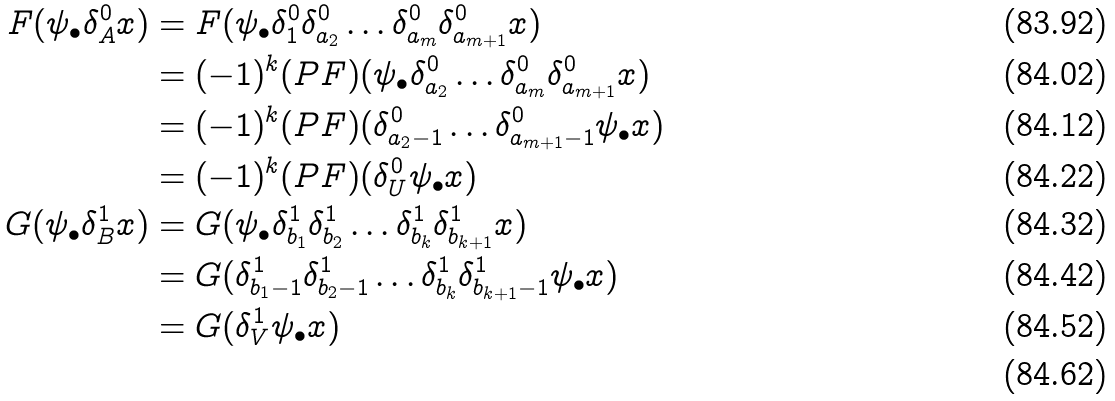Convert formula to latex. <formula><loc_0><loc_0><loc_500><loc_500>F ( \psi _ { \bullet } \delta ^ { 0 } _ { A } x ) & = F ( \psi _ { \bullet } \delta ^ { 0 } _ { 1 } \delta ^ { 0 } _ { a _ { 2 } } \dots \delta ^ { 0 } _ { a _ { m } } \delta ^ { 0 } _ { a _ { m + 1 } } x ) \\ & = ( - 1 ) ^ { k } ( P F ) ( \psi _ { \bullet } \delta ^ { 0 } _ { a _ { 2 } } \dots \delta ^ { 0 } _ { a _ { m } } \delta ^ { 0 } _ { a _ { m + 1 } } x ) \\ & = ( - 1 ) ^ { k } ( P F ) ( \delta ^ { 0 } _ { a _ { 2 } - 1 } \dots \delta ^ { 0 } _ { a _ { m + 1 } - 1 } \psi _ { \bullet } x ) \\ & = ( - 1 ) ^ { k } ( P F ) ( \delta ^ { 0 } _ { U } \psi _ { \bullet } x ) \\ G ( \psi _ { \bullet } \delta ^ { 1 } _ { B } x ) & = G ( \psi _ { \bullet } \delta ^ { 1 } _ { b _ { 1 } } \delta ^ { 1 } _ { b _ { 2 } } \dots \delta ^ { 1 } _ { b _ { k } } \delta ^ { 1 } _ { b _ { k + 1 } } x ) \\ & = G ( \delta ^ { 1 } _ { b _ { 1 } - 1 } \delta ^ { 1 } _ { b _ { 2 } - 1 } \dots \delta ^ { 1 } _ { b _ { k } } \delta ^ { 1 } _ { b _ { k + 1 } - 1 } \psi _ { \bullet } x ) \\ & = G ( \delta ^ { 1 } _ { V } \psi _ { \bullet } x ) \\</formula> 